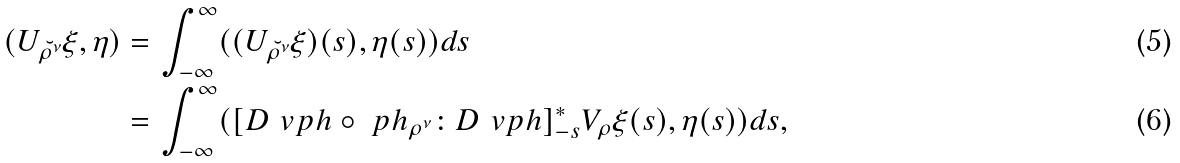<formula> <loc_0><loc_0><loc_500><loc_500>( U _ { \breve { \rho ^ { \nu } } } \xi , \eta ) = & \, \int _ { - \infty } ^ { \infty } ( ( U _ { \breve { \rho ^ { \nu } } } \xi ) ( s ) , \eta ( s ) ) d s \\ = & \, \int _ { - \infty } ^ { \infty } ( [ D \ v p h \circ \ p h _ { \rho ^ { \nu } } \colon D \ v p h ] _ { - s } ^ { * } V _ { \rho } \xi ( s ) , \eta ( s ) ) d s ,</formula> 